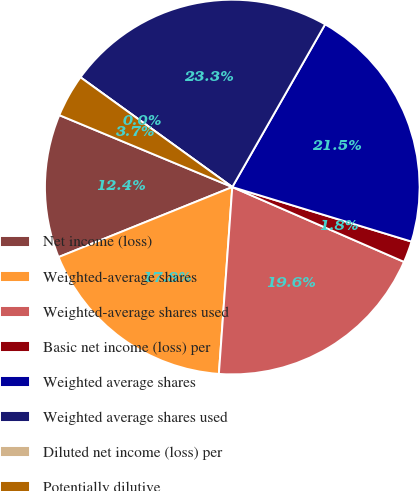Convert chart. <chart><loc_0><loc_0><loc_500><loc_500><pie_chart><fcel>Net income (loss)<fcel>Weighted-average shares<fcel>Weighted-average shares used<fcel>Basic net income (loss) per<fcel>Weighted average shares<fcel>Weighted average shares used<fcel>Diluted net income (loss) per<fcel>Potentially dilutive<nl><fcel>12.37%<fcel>17.76%<fcel>19.6%<fcel>1.84%<fcel>21.45%<fcel>23.29%<fcel>0.0%<fcel>3.69%<nl></chart> 